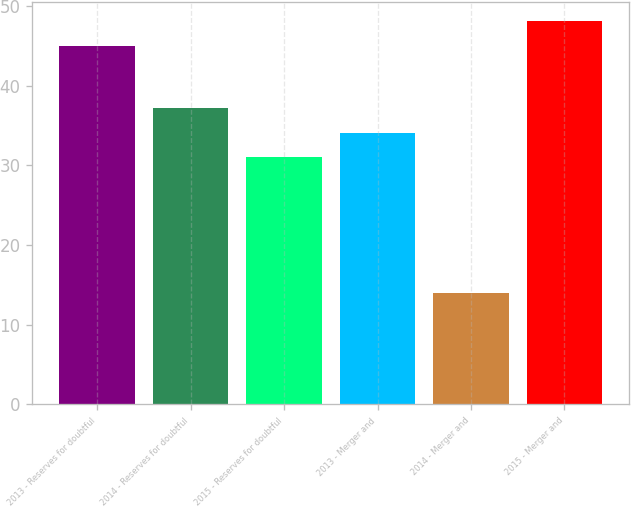Convert chart to OTSL. <chart><loc_0><loc_0><loc_500><loc_500><bar_chart><fcel>2013 - Reserves for doubtful<fcel>2014 - Reserves for doubtful<fcel>2015 - Reserves for doubtful<fcel>2013 - Merger and<fcel>2014 - Merger and<fcel>2015 - Merger and<nl><fcel>45<fcel>37.2<fcel>31<fcel>34.1<fcel>14<fcel>48.1<nl></chart> 